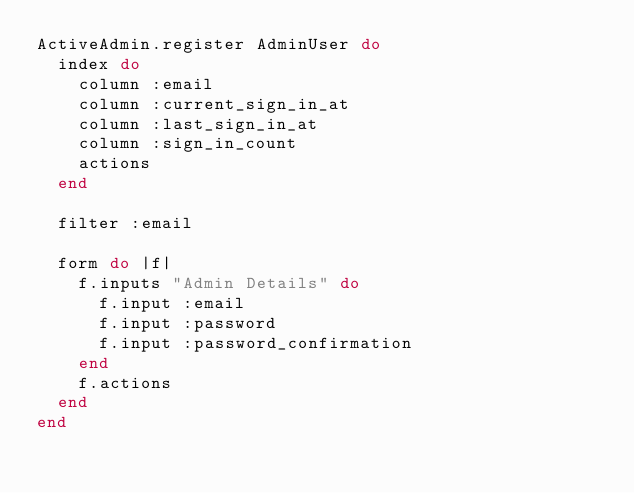<code> <loc_0><loc_0><loc_500><loc_500><_Ruby_>ActiveAdmin.register AdminUser do
  index do
    column :email
    column :current_sign_in_at
    column :last_sign_in_at
    column :sign_in_count
    actions
  end

  filter :email

  form do |f|
    f.inputs "Admin Details" do
      f.input :email
      f.input :password
      f.input :password_confirmation
    end
    f.actions
  end
end
</code> 